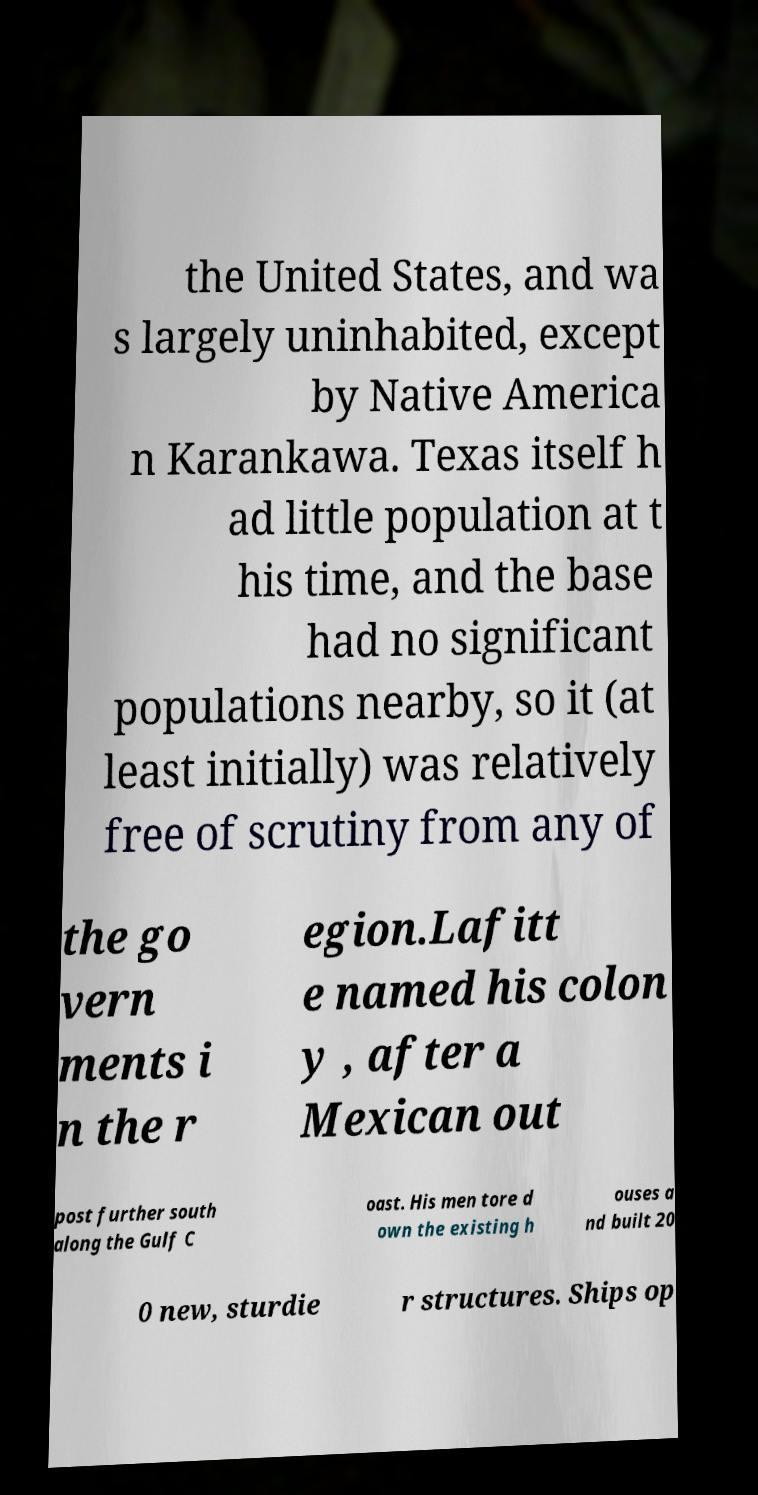Can you read and provide the text displayed in the image?This photo seems to have some interesting text. Can you extract and type it out for me? the United States, and wa s largely uninhabited, except by Native America n Karankawa. Texas itself h ad little population at t his time, and the base had no significant populations nearby, so it (at least initially) was relatively free of scrutiny from any of the go vern ments i n the r egion.Lafitt e named his colon y , after a Mexican out post further south along the Gulf C oast. His men tore d own the existing h ouses a nd built 20 0 new, sturdie r structures. Ships op 